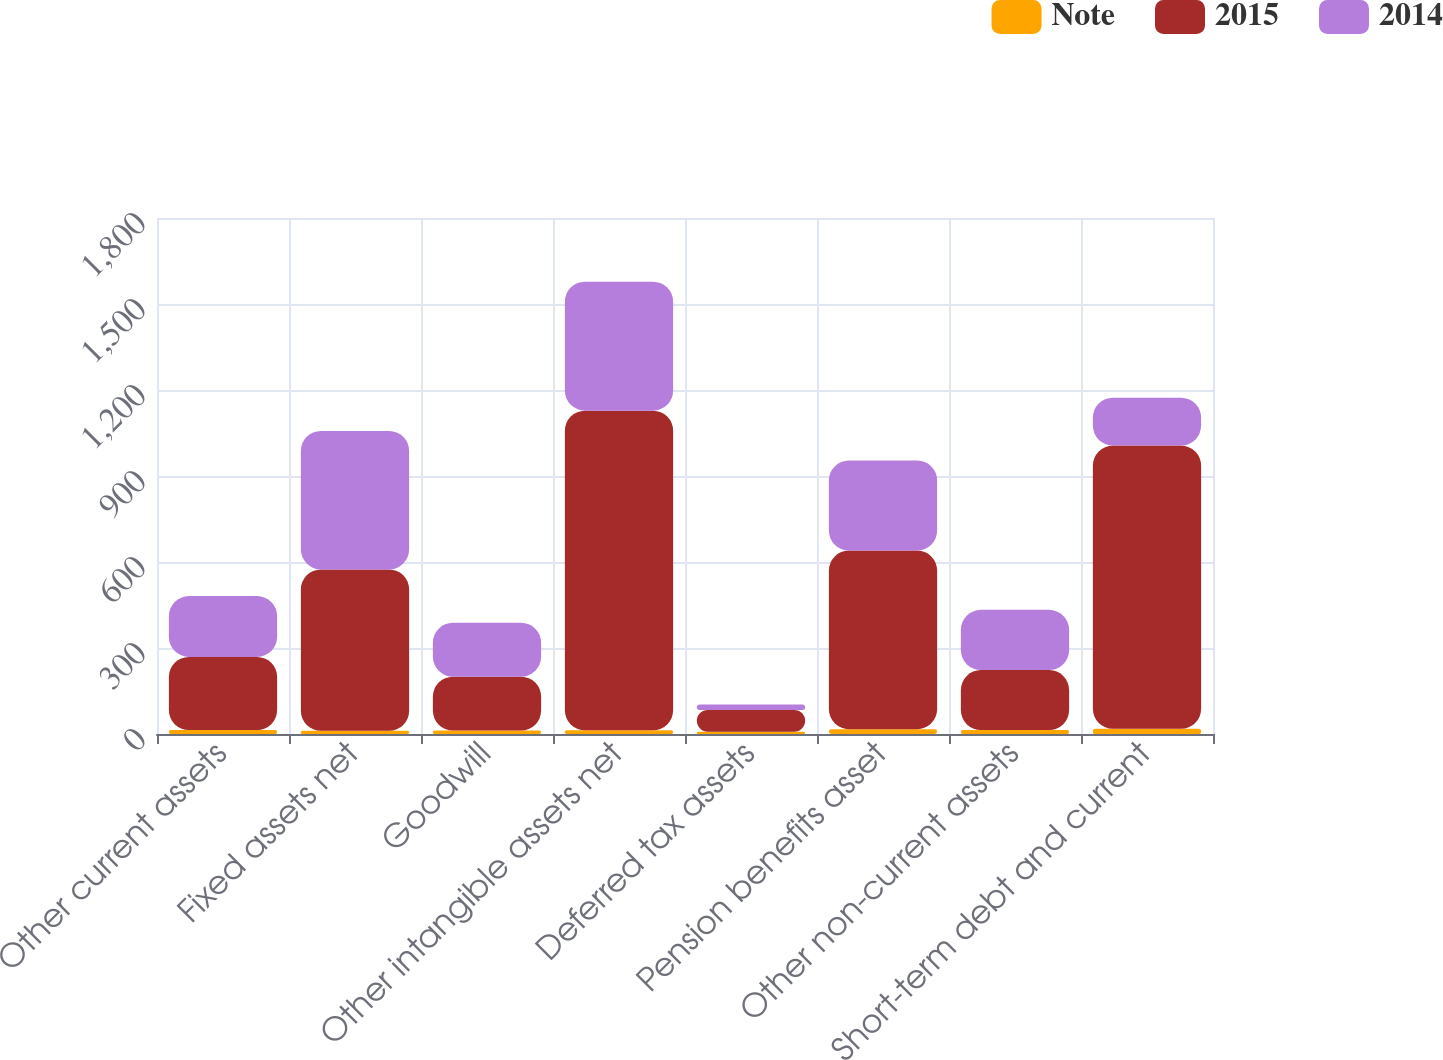Convert chart. <chart><loc_0><loc_0><loc_500><loc_500><stacked_bar_chart><ecel><fcel>Other current assets<fcel>Fixed assets net<fcel>Goodwill<fcel>Other intangible assets net<fcel>Deferred tax assets<fcel>Pension benefits asset<fcel>Other non-current assets<fcel>Short-term debt and current<nl><fcel>Note<fcel>14<fcel>11<fcel>12<fcel>13<fcel>8<fcel>17<fcel>14<fcel>18<nl><fcel>2015<fcel>255<fcel>563<fcel>188<fcel>1115<fcel>76<fcel>623<fcel>209<fcel>988<nl><fcel>2014<fcel>212<fcel>483<fcel>188<fcel>450<fcel>19<fcel>314<fcel>210<fcel>167<nl></chart> 